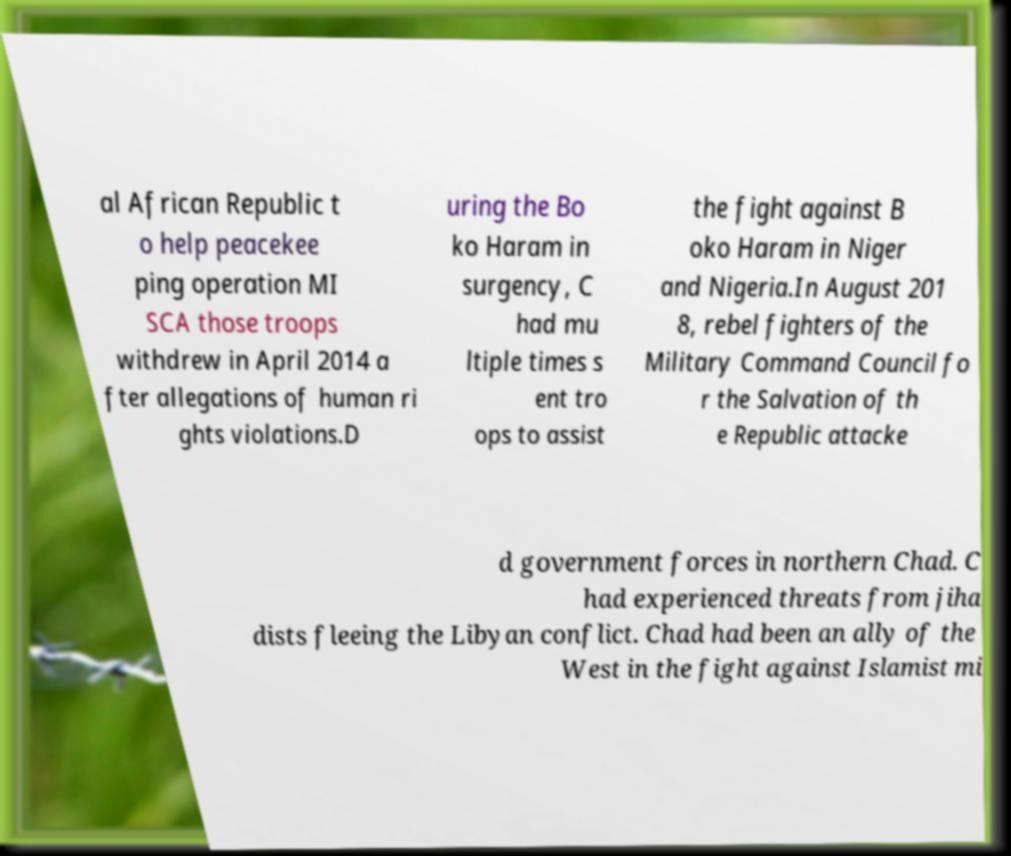Please read and relay the text visible in this image. What does it say? al African Republic t o help peacekee ping operation MI SCA those troops withdrew in April 2014 a fter allegations of human ri ghts violations.D uring the Bo ko Haram in surgency, C had mu ltiple times s ent tro ops to assist the fight against B oko Haram in Niger and Nigeria.In August 201 8, rebel fighters of the Military Command Council fo r the Salvation of th e Republic attacke d government forces in northern Chad. C had experienced threats from jiha dists fleeing the Libyan conflict. Chad had been an ally of the West in the fight against Islamist mi 